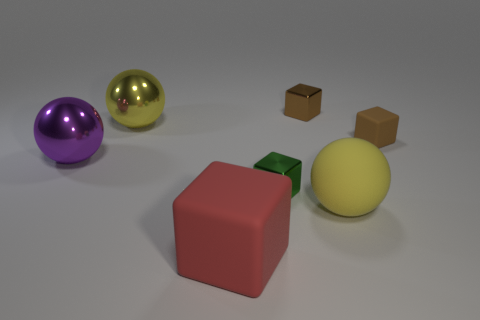Subtract all brown rubber cubes. How many cubes are left? 3 Subtract all brown blocks. How many blocks are left? 2 Subtract all tiny matte blocks. Subtract all purple objects. How many objects are left? 5 Add 7 tiny shiny things. How many tiny shiny things are left? 9 Add 5 tiny brown metallic cubes. How many tiny brown metallic cubes exist? 6 Add 1 red matte objects. How many objects exist? 8 Subtract 1 green blocks. How many objects are left? 6 Subtract all balls. How many objects are left? 4 Subtract 2 balls. How many balls are left? 1 Subtract all red cubes. Subtract all blue spheres. How many cubes are left? 3 